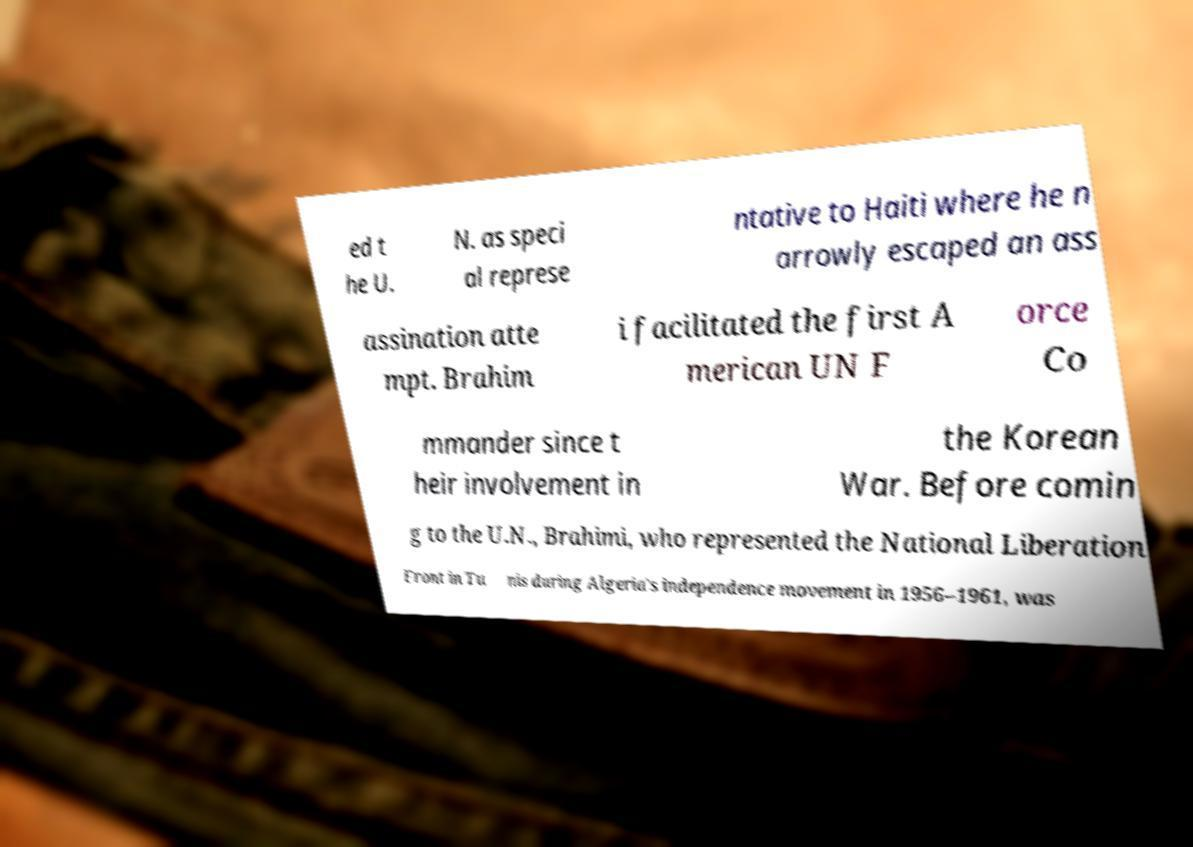What messages or text are displayed in this image? I need them in a readable, typed format. ed t he U. N. as speci al represe ntative to Haiti where he n arrowly escaped an ass assination atte mpt. Brahim i facilitated the first A merican UN F orce Co mmander since t heir involvement in the Korean War. Before comin g to the U.N., Brahimi, who represented the National Liberation Front in Tu nis during Algeria's independence movement in 1956–1961, was 